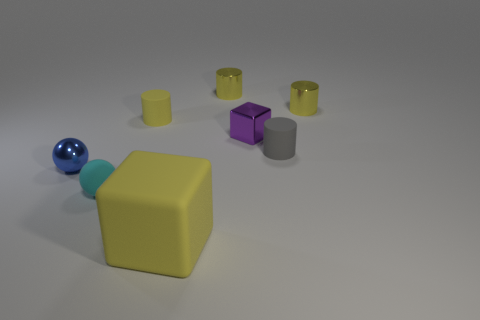There is a purple thing that is the same shape as the large yellow matte thing; what is its material?
Provide a short and direct response. Metal. What size is the cylinder that is on the left side of the large matte block to the left of the metal block?
Provide a succinct answer. Small. The thing that is left of the matte block and in front of the blue thing is what color?
Your answer should be compact. Cyan. How many other things are the same size as the purple metal cube?
Keep it short and to the point. 6. There is a cyan matte sphere; is it the same size as the yellow rubber object in front of the blue thing?
Give a very brief answer. No. What color is the ball that is the same size as the blue shiny object?
Ensure brevity in your answer.  Cyan. What is the size of the yellow rubber cube?
Ensure brevity in your answer.  Large. Are the tiny cylinder on the left side of the rubber cube and the big yellow cube made of the same material?
Ensure brevity in your answer.  Yes. Do the large matte object and the purple thing have the same shape?
Your answer should be compact. Yes. What shape is the tiny rubber thing on the left side of the rubber cylinder to the left of the yellow metallic cylinder to the left of the gray object?
Ensure brevity in your answer.  Sphere. 